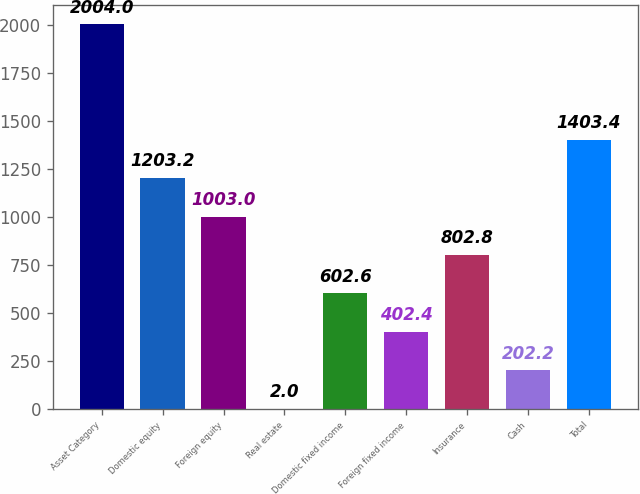Convert chart. <chart><loc_0><loc_0><loc_500><loc_500><bar_chart><fcel>Asset Category<fcel>Domestic equity<fcel>Foreign equity<fcel>Real estate<fcel>Domestic fixed income<fcel>Foreign fixed income<fcel>Insurance<fcel>Cash<fcel>Total<nl><fcel>2004<fcel>1203.2<fcel>1003<fcel>2<fcel>602.6<fcel>402.4<fcel>802.8<fcel>202.2<fcel>1403.4<nl></chart> 